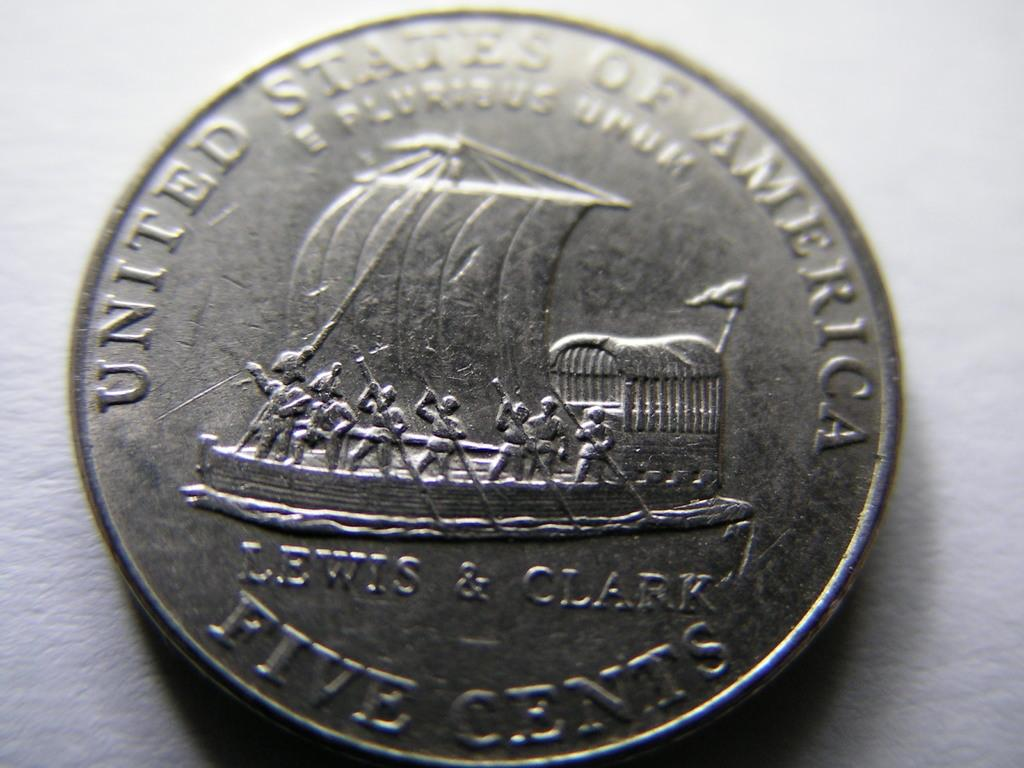<image>
Provide a brief description of the given image. a silver five cent coin with United States of America on it 